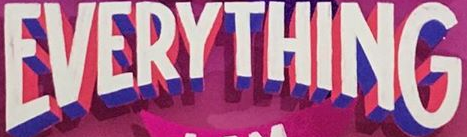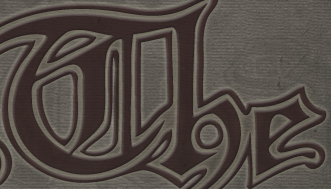What words are shown in these images in order, separated by a semicolon? EVERYTHING; The 